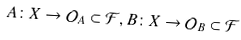<formula> <loc_0><loc_0><loc_500><loc_500>A \colon X \to \mathcal { O } _ { A } \subset \mathcal { F } , B \colon X \to \mathcal { O } _ { B } \subset \mathcal { F }</formula> 